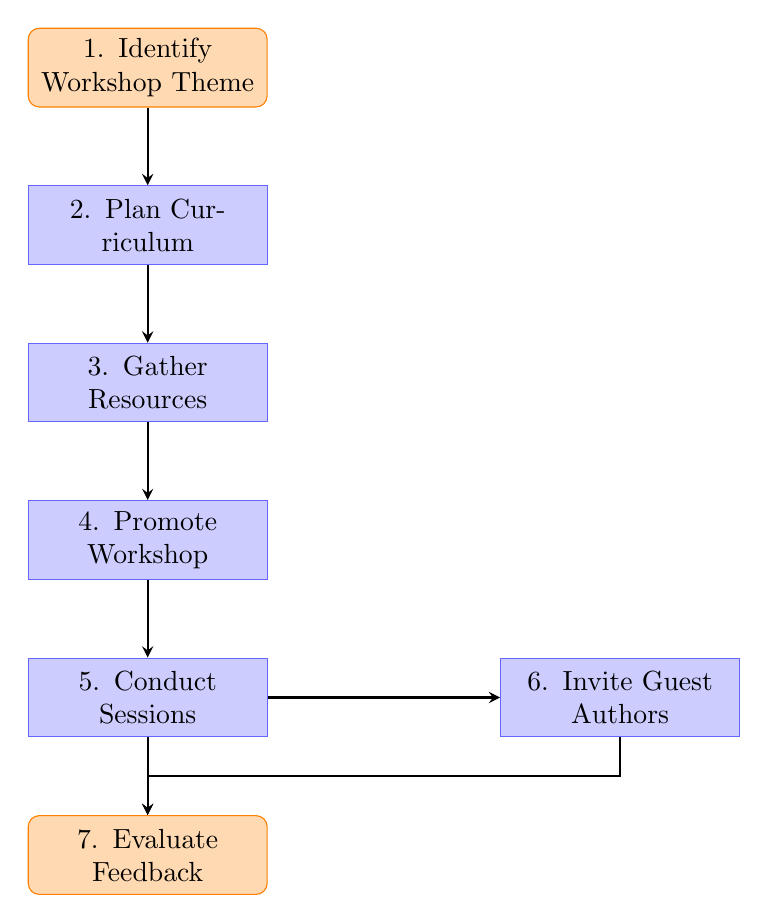What is the first step in the diagram? The first step, represented as the top node in the flow chart, is "Identify Workshop Theme," which initiates the process of conducting a literary workshop.
Answer: Identify Workshop Theme How many total steps are there in the flow chart? Counting all the distinct nodes in the diagram, there are seven steps listed, from identifying the theme to evaluating feedback.
Answer: 7 What is the last step before evaluating feedback? The last step before evaluating feedback involves conducting interactive sessions, denoted as "Conduct Sessions," which directly precedes the evaluation stage.
Answer: Conduct Sessions Which step comes after gathering resources? After the "Gather Resources" step, the next step is "Promote Workshop," which indicates the flow of actions taken in preparation for the workshop.
Answer: Promote Workshop Which two steps are parallel to each other in the diagram? The two steps that are positioned parallel to each other are "Conduct Sessions" and "Invite Guest Authors," illustrating simultaneous activities that can take place during the workshop.
Answer: Conduct Sessions and Invite Guest Authors What is the connection between "Conduct Sessions" and "Evaluate Feedback"? "Conduct Sessions" leads directly to "Evaluate Feedback," showing that after the sessions are completed, gathering participant feedback is a subsequent action in the process.
Answer: Conduct Sessions leads to Evaluate Feedback In which thematic area does the entire diagram focus? The overall focus of the diagram is on conducting a literary workshop, with particular emphasis on multicultural literature and themes that engage diverse audiences.
Answer: Literary Workshop 